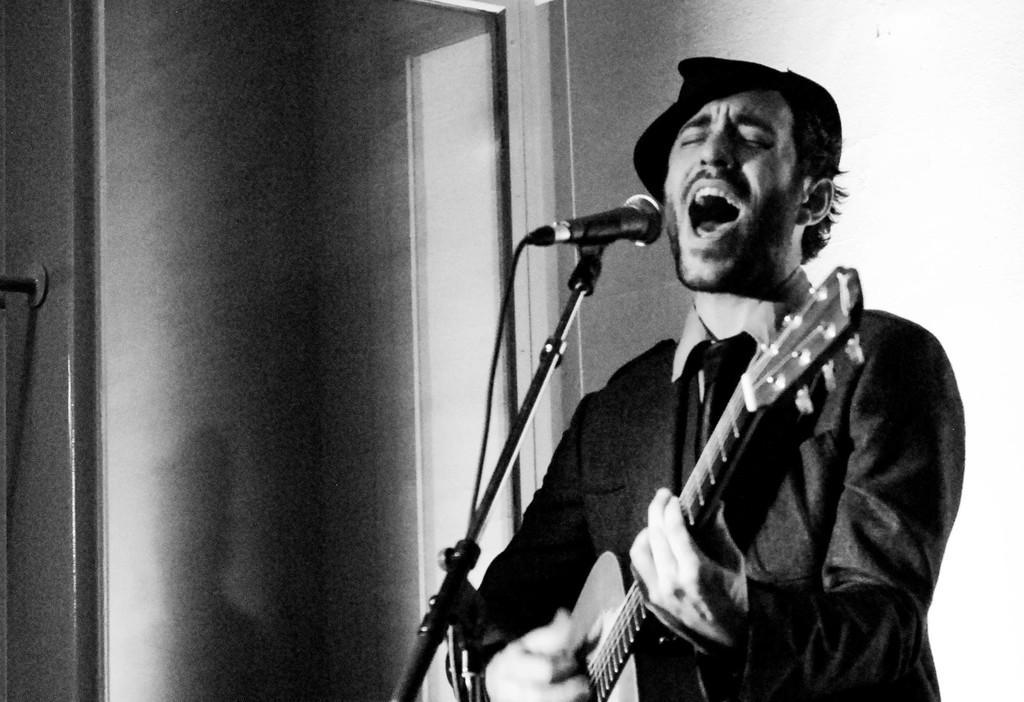Please provide a concise description of this image. In this image I can see the person standing in front of the mic and playing guitar. 